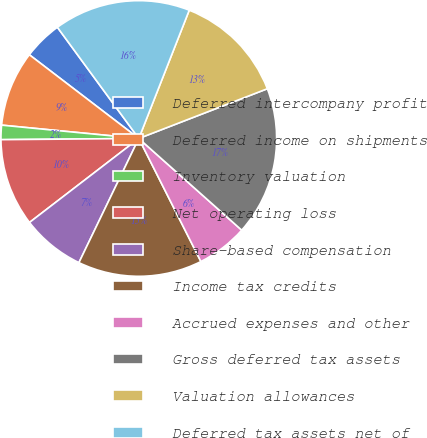Convert chart. <chart><loc_0><loc_0><loc_500><loc_500><pie_chart><fcel>Deferred intercompany profit<fcel>Deferred income on shipments<fcel>Inventory valuation<fcel>Net operating loss<fcel>Share-based compensation<fcel>Income tax credits<fcel>Accrued expenses and other<fcel>Gross deferred tax assets<fcel>Valuation allowances<fcel>Deferred tax assets net of<nl><fcel>4.55%<fcel>8.85%<fcel>1.68%<fcel>10.29%<fcel>7.42%<fcel>14.59%<fcel>5.98%<fcel>17.46%<fcel>13.16%<fcel>16.02%<nl></chart> 